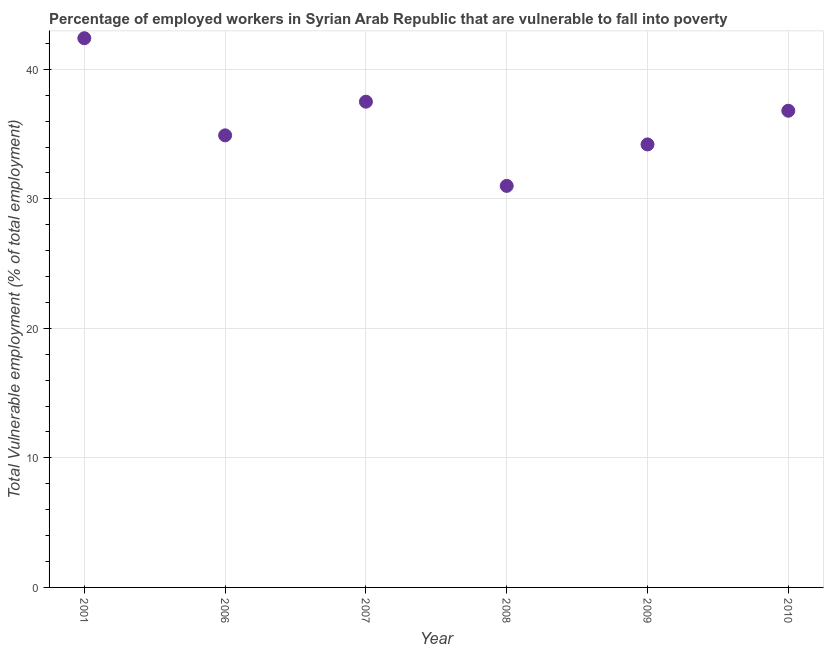What is the total vulnerable employment in 2009?
Your answer should be very brief. 34.2. Across all years, what is the maximum total vulnerable employment?
Offer a very short reply. 42.4. In which year was the total vulnerable employment maximum?
Your response must be concise. 2001. In which year was the total vulnerable employment minimum?
Provide a short and direct response. 2008. What is the sum of the total vulnerable employment?
Ensure brevity in your answer.  216.8. What is the difference between the total vulnerable employment in 2006 and 2008?
Give a very brief answer. 3.9. What is the average total vulnerable employment per year?
Your answer should be very brief. 36.13. What is the median total vulnerable employment?
Ensure brevity in your answer.  35.85. What is the ratio of the total vulnerable employment in 2001 to that in 2007?
Your answer should be compact. 1.13. Is the total vulnerable employment in 2007 less than that in 2009?
Offer a very short reply. No. What is the difference between the highest and the second highest total vulnerable employment?
Ensure brevity in your answer.  4.9. Is the sum of the total vulnerable employment in 2008 and 2010 greater than the maximum total vulnerable employment across all years?
Provide a short and direct response. Yes. What is the difference between the highest and the lowest total vulnerable employment?
Your answer should be very brief. 11.4. In how many years, is the total vulnerable employment greater than the average total vulnerable employment taken over all years?
Your response must be concise. 3. Does the total vulnerable employment monotonically increase over the years?
Provide a succinct answer. No. How many dotlines are there?
Provide a succinct answer. 1. How many years are there in the graph?
Give a very brief answer. 6. Does the graph contain grids?
Give a very brief answer. Yes. What is the title of the graph?
Offer a terse response. Percentage of employed workers in Syrian Arab Republic that are vulnerable to fall into poverty. What is the label or title of the X-axis?
Give a very brief answer. Year. What is the label or title of the Y-axis?
Keep it short and to the point. Total Vulnerable employment (% of total employment). What is the Total Vulnerable employment (% of total employment) in 2001?
Give a very brief answer. 42.4. What is the Total Vulnerable employment (% of total employment) in 2006?
Offer a terse response. 34.9. What is the Total Vulnerable employment (% of total employment) in 2007?
Provide a short and direct response. 37.5. What is the Total Vulnerable employment (% of total employment) in 2009?
Your response must be concise. 34.2. What is the Total Vulnerable employment (% of total employment) in 2010?
Provide a succinct answer. 36.8. What is the difference between the Total Vulnerable employment (% of total employment) in 2001 and 2008?
Your answer should be very brief. 11.4. What is the difference between the Total Vulnerable employment (% of total employment) in 2001 and 2009?
Offer a very short reply. 8.2. What is the difference between the Total Vulnerable employment (% of total employment) in 2001 and 2010?
Your answer should be compact. 5.6. What is the difference between the Total Vulnerable employment (% of total employment) in 2006 and 2010?
Your answer should be compact. -1.9. What is the difference between the Total Vulnerable employment (% of total employment) in 2007 and 2008?
Your response must be concise. 6.5. What is the difference between the Total Vulnerable employment (% of total employment) in 2009 and 2010?
Your answer should be very brief. -2.6. What is the ratio of the Total Vulnerable employment (% of total employment) in 2001 to that in 2006?
Your response must be concise. 1.22. What is the ratio of the Total Vulnerable employment (% of total employment) in 2001 to that in 2007?
Provide a succinct answer. 1.13. What is the ratio of the Total Vulnerable employment (% of total employment) in 2001 to that in 2008?
Ensure brevity in your answer.  1.37. What is the ratio of the Total Vulnerable employment (% of total employment) in 2001 to that in 2009?
Provide a succinct answer. 1.24. What is the ratio of the Total Vulnerable employment (% of total employment) in 2001 to that in 2010?
Give a very brief answer. 1.15. What is the ratio of the Total Vulnerable employment (% of total employment) in 2006 to that in 2007?
Offer a terse response. 0.93. What is the ratio of the Total Vulnerable employment (% of total employment) in 2006 to that in 2008?
Make the answer very short. 1.13. What is the ratio of the Total Vulnerable employment (% of total employment) in 2006 to that in 2010?
Provide a short and direct response. 0.95. What is the ratio of the Total Vulnerable employment (% of total employment) in 2007 to that in 2008?
Ensure brevity in your answer.  1.21. What is the ratio of the Total Vulnerable employment (% of total employment) in 2007 to that in 2009?
Ensure brevity in your answer.  1.1. What is the ratio of the Total Vulnerable employment (% of total employment) in 2007 to that in 2010?
Offer a very short reply. 1.02. What is the ratio of the Total Vulnerable employment (% of total employment) in 2008 to that in 2009?
Provide a short and direct response. 0.91. What is the ratio of the Total Vulnerable employment (% of total employment) in 2008 to that in 2010?
Provide a short and direct response. 0.84. What is the ratio of the Total Vulnerable employment (% of total employment) in 2009 to that in 2010?
Your answer should be very brief. 0.93. 